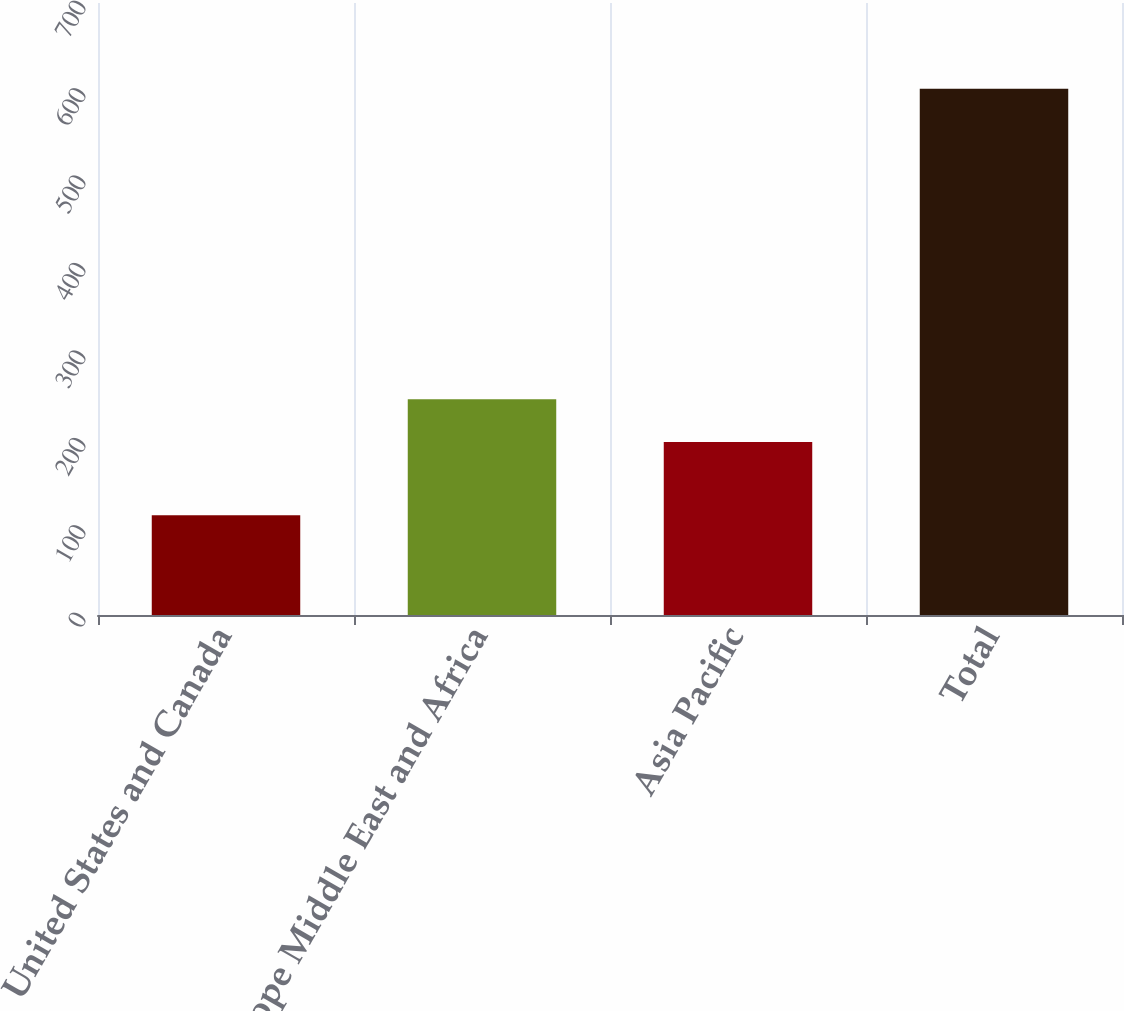Convert chart to OTSL. <chart><loc_0><loc_0><loc_500><loc_500><bar_chart><fcel>United States and Canada<fcel>Europe Middle East and Africa<fcel>Asia Pacific<fcel>Total<nl><fcel>114<fcel>246.8<fcel>198<fcel>602<nl></chart> 